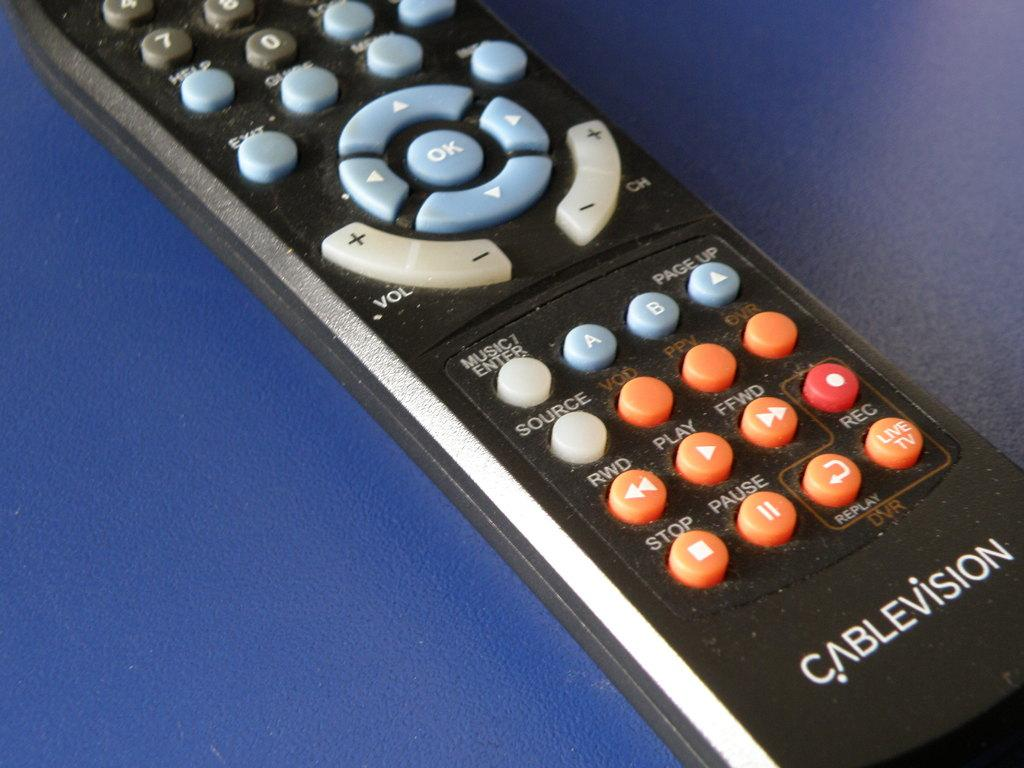<image>
Share a concise interpretation of the image provided. Black remote controller with orange buttons and the words "Cablevision" on the bottom. 